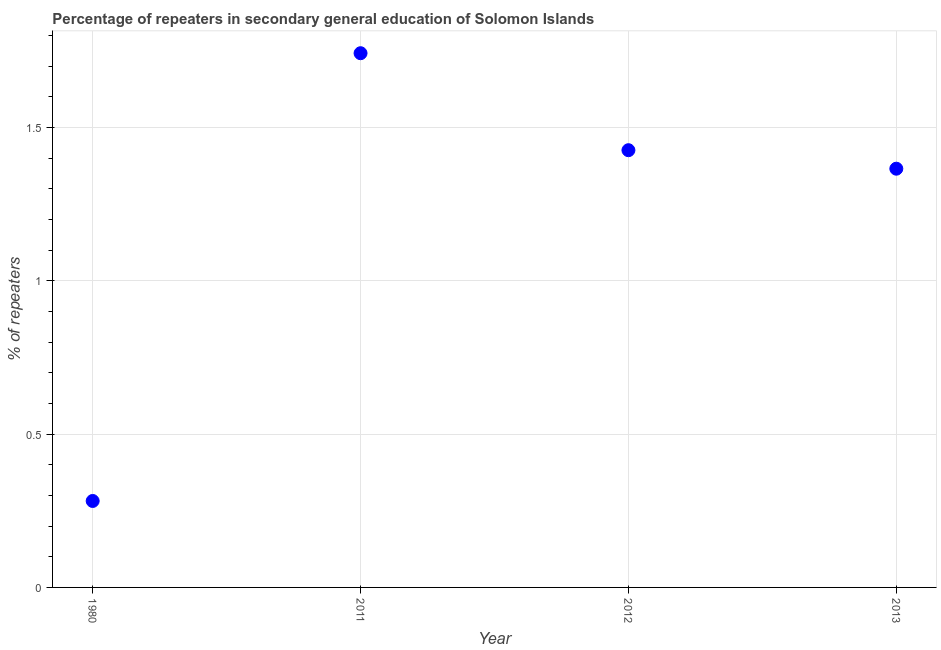What is the percentage of repeaters in 1980?
Keep it short and to the point. 0.28. Across all years, what is the maximum percentage of repeaters?
Your response must be concise. 1.74. Across all years, what is the minimum percentage of repeaters?
Make the answer very short. 0.28. What is the sum of the percentage of repeaters?
Make the answer very short. 4.82. What is the difference between the percentage of repeaters in 1980 and 2013?
Give a very brief answer. -1.08. What is the average percentage of repeaters per year?
Offer a very short reply. 1.2. What is the median percentage of repeaters?
Your response must be concise. 1.4. In how many years, is the percentage of repeaters greater than 0.7 %?
Make the answer very short. 3. Do a majority of the years between 2011 and 2012 (inclusive) have percentage of repeaters greater than 1 %?
Offer a very short reply. Yes. What is the ratio of the percentage of repeaters in 2011 to that in 2013?
Provide a short and direct response. 1.28. Is the percentage of repeaters in 1980 less than that in 2012?
Your response must be concise. Yes. Is the difference between the percentage of repeaters in 1980 and 2011 greater than the difference between any two years?
Keep it short and to the point. Yes. What is the difference between the highest and the second highest percentage of repeaters?
Ensure brevity in your answer.  0.32. Is the sum of the percentage of repeaters in 2012 and 2013 greater than the maximum percentage of repeaters across all years?
Provide a short and direct response. Yes. What is the difference between the highest and the lowest percentage of repeaters?
Give a very brief answer. 1.46. In how many years, is the percentage of repeaters greater than the average percentage of repeaters taken over all years?
Your answer should be compact. 3. Does the percentage of repeaters monotonically increase over the years?
Provide a succinct answer. No. How many dotlines are there?
Your answer should be very brief. 1. How many years are there in the graph?
Offer a terse response. 4. What is the difference between two consecutive major ticks on the Y-axis?
Provide a short and direct response. 0.5. Does the graph contain any zero values?
Ensure brevity in your answer.  No. Does the graph contain grids?
Your answer should be very brief. Yes. What is the title of the graph?
Provide a succinct answer. Percentage of repeaters in secondary general education of Solomon Islands. What is the label or title of the X-axis?
Provide a succinct answer. Year. What is the label or title of the Y-axis?
Keep it short and to the point. % of repeaters. What is the % of repeaters in 1980?
Keep it short and to the point. 0.28. What is the % of repeaters in 2011?
Make the answer very short. 1.74. What is the % of repeaters in 2012?
Keep it short and to the point. 1.43. What is the % of repeaters in 2013?
Offer a very short reply. 1.37. What is the difference between the % of repeaters in 1980 and 2011?
Provide a short and direct response. -1.46. What is the difference between the % of repeaters in 1980 and 2012?
Offer a terse response. -1.14. What is the difference between the % of repeaters in 1980 and 2013?
Your answer should be compact. -1.08. What is the difference between the % of repeaters in 2011 and 2012?
Provide a succinct answer. 0.32. What is the difference between the % of repeaters in 2011 and 2013?
Offer a terse response. 0.38. What is the difference between the % of repeaters in 2012 and 2013?
Keep it short and to the point. 0.06. What is the ratio of the % of repeaters in 1980 to that in 2011?
Keep it short and to the point. 0.16. What is the ratio of the % of repeaters in 1980 to that in 2012?
Your answer should be very brief. 0.2. What is the ratio of the % of repeaters in 1980 to that in 2013?
Keep it short and to the point. 0.21. What is the ratio of the % of repeaters in 2011 to that in 2012?
Offer a terse response. 1.22. What is the ratio of the % of repeaters in 2011 to that in 2013?
Keep it short and to the point. 1.28. What is the ratio of the % of repeaters in 2012 to that in 2013?
Your answer should be very brief. 1.04. 